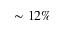<formula> <loc_0><loc_0><loc_500><loc_500>\sim 1 2 \%</formula> 